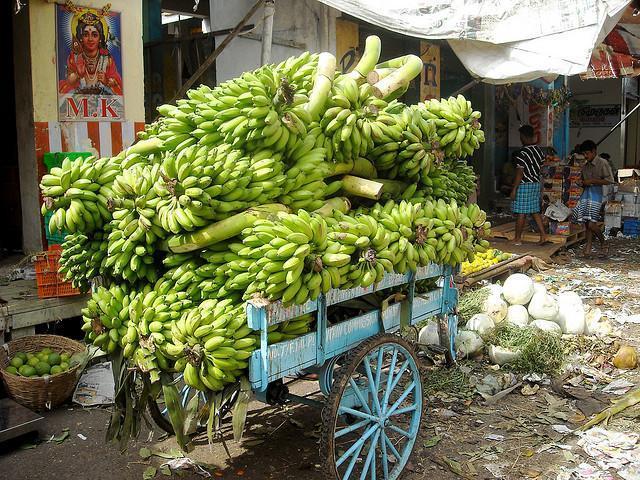How many people can be seen?
Give a very brief answer. 2. How many bananas are there?
Give a very brief answer. 10. 